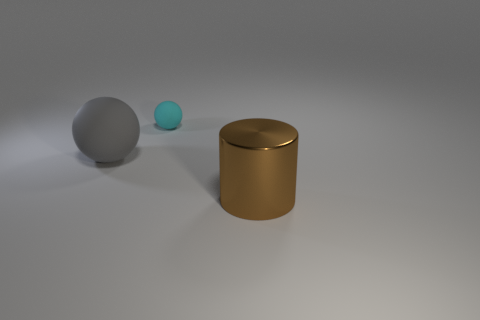What material is the object that is behind the large thing that is behind the object to the right of the tiny matte object?
Make the answer very short. Rubber. Are there the same number of big gray matte spheres that are in front of the gray sphere and yellow metallic cylinders?
Offer a very short reply. Yes. Does the large thing behind the cylinder have the same material as the big object that is in front of the gray matte thing?
Provide a short and direct response. No. Is there anything else that has the same material as the large brown thing?
Your response must be concise. No. Does the rubber thing on the right side of the gray rubber thing have the same shape as the object on the left side of the cyan thing?
Keep it short and to the point. Yes. Are there fewer large spheres behind the big gray object than tiny metal objects?
Make the answer very short. No. What is the size of the object that is in front of the gray sphere?
Your response must be concise. Large. What is the shape of the large object that is behind the large object that is right of the big thing behind the big brown cylinder?
Provide a succinct answer. Sphere. What is the shape of the object that is both in front of the small ball and behind the brown shiny thing?
Provide a short and direct response. Sphere. Is there a metallic sphere of the same size as the brown metal object?
Provide a succinct answer. No. 